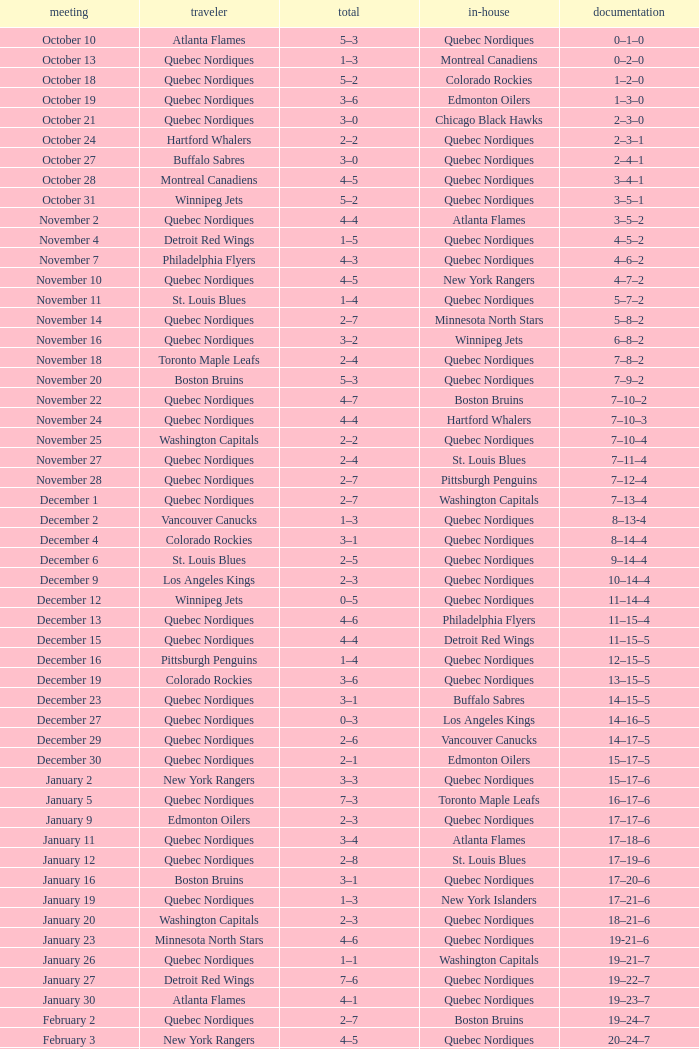Which Record has a Home of edmonton oilers, and a Score of 3–6? 1–3–0. 